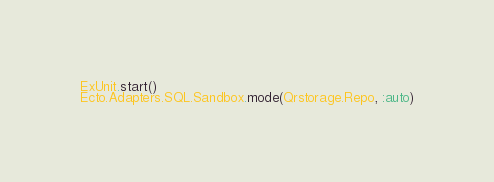<code> <loc_0><loc_0><loc_500><loc_500><_Elixir_>ExUnit.start()
Ecto.Adapters.SQL.Sandbox.mode(Qrstorage.Repo, :auto)
</code> 